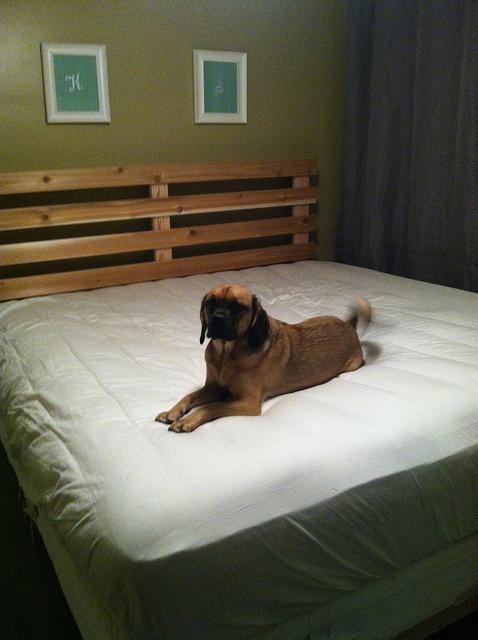How many people are standing?
Give a very brief answer. 0. 